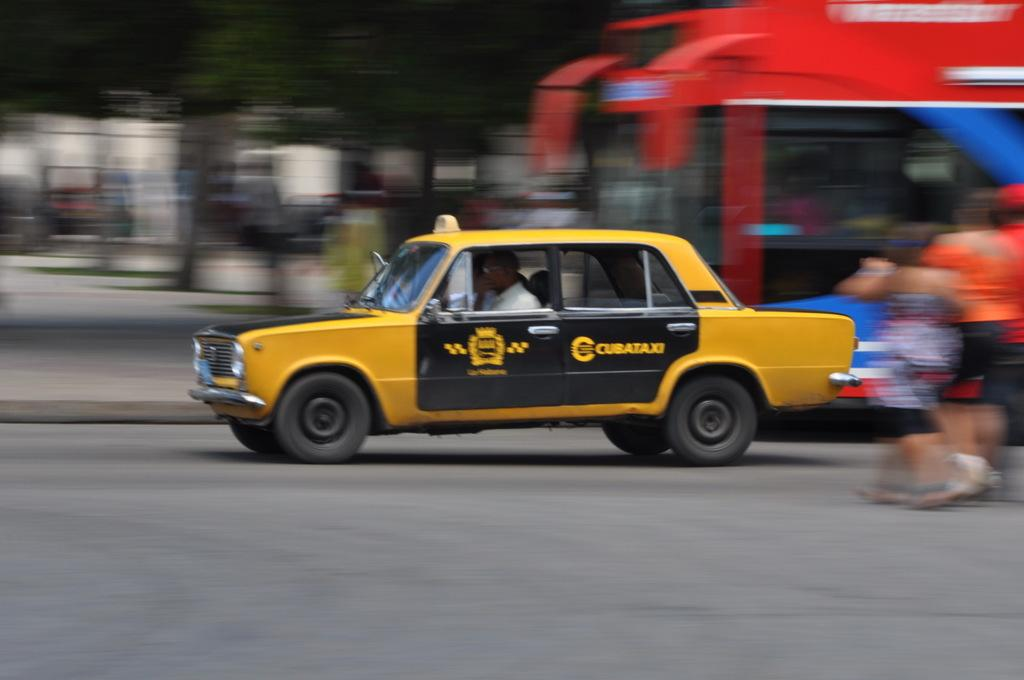What is the main subject of the picture? The main subject of the picture is a car. Can you describe the appearance of the car? The car is yellow and black in color. Where is the car located in the image? The car is on the road. What is the car doing in the image? The car is in motion (running). Are there any other elements present in the image? Yes, there are people walking on the road. How many letters can be seen on the cherry in the image? There is no cherry present in the image, and therefore no letters can be seen on it. 